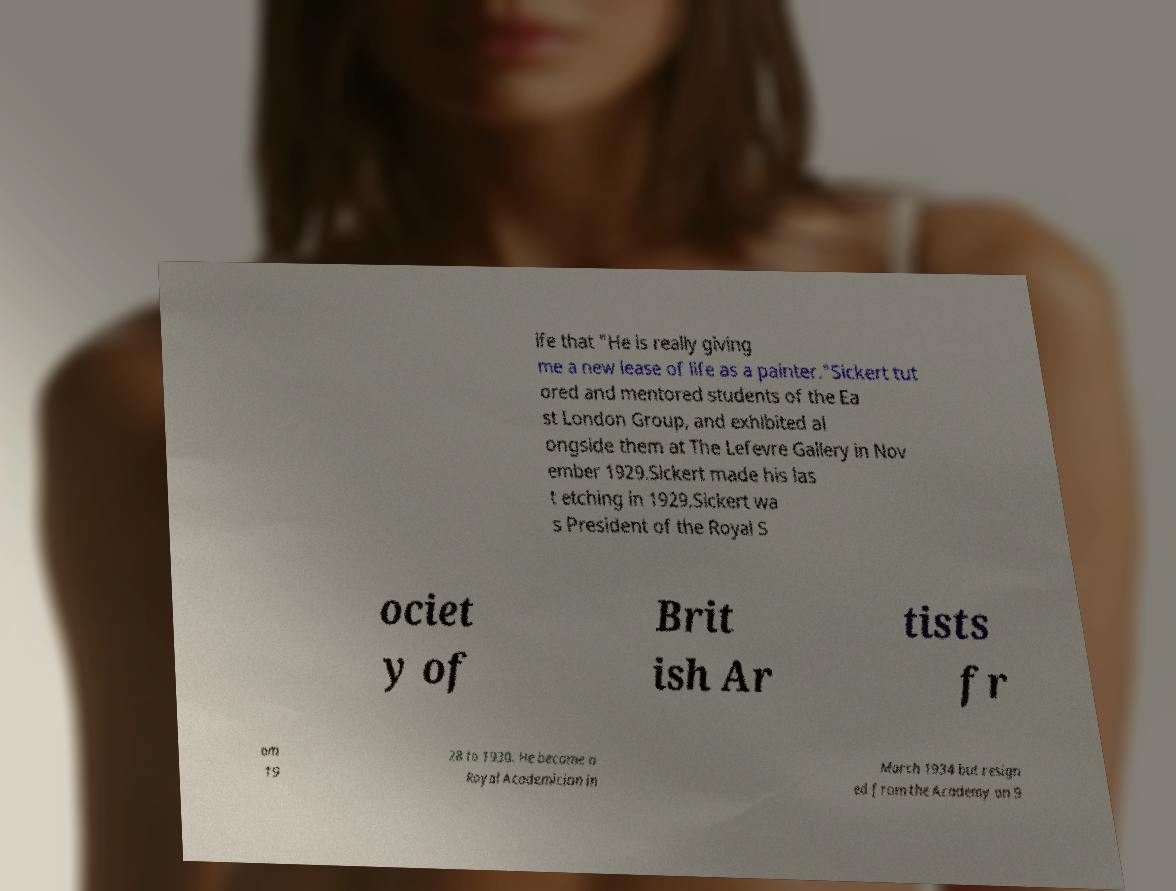Can you read and provide the text displayed in the image?This photo seems to have some interesting text. Can you extract and type it out for me? ife that "He is really giving me a new lease of life as a painter."Sickert tut ored and mentored students of the Ea st London Group, and exhibited al ongside them at The Lefevre Gallery in Nov ember 1929.Sickert made his las t etching in 1929.Sickert wa s President of the Royal S ociet y of Brit ish Ar tists fr om 19 28 to 1930. He became a Royal Academician in March 1934 but resign ed from the Academy on 9 